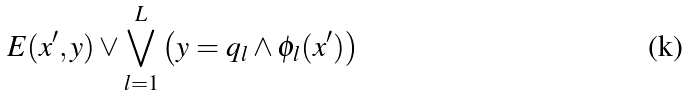Convert formula to latex. <formula><loc_0><loc_0><loc_500><loc_500>E ( x ^ { \prime } , y ) \vee \bigvee _ { l = 1 } ^ { L } \left ( y = q _ { l } \wedge \phi _ { l } ( x ^ { \prime } ) \right )</formula> 